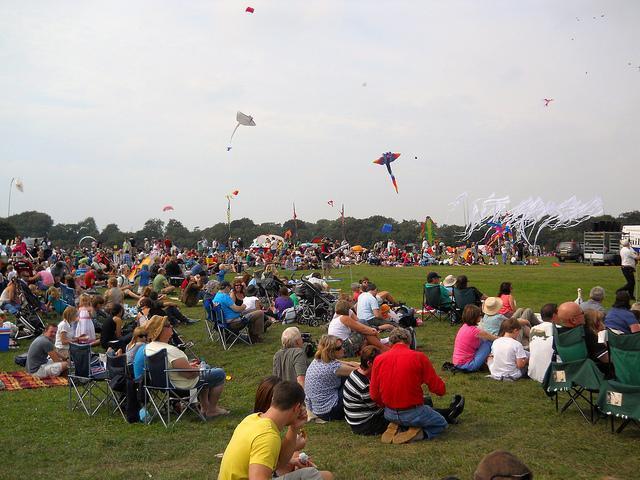What type toys unite these people today?
Answer the question by selecting the correct answer among the 4 following choices.
Options: Trucks, chairs, toys, drones. Toys. Why are there more people than kites?
Choose the right answer and clarify with the format: 'Answer: answer
Rationale: rationale.'
Options: Lost some, lazy people, some hidden, mostly spectators. Answer: mostly spectators.
Rationale: Not everyone is flying one, some are just sitting to watch. 